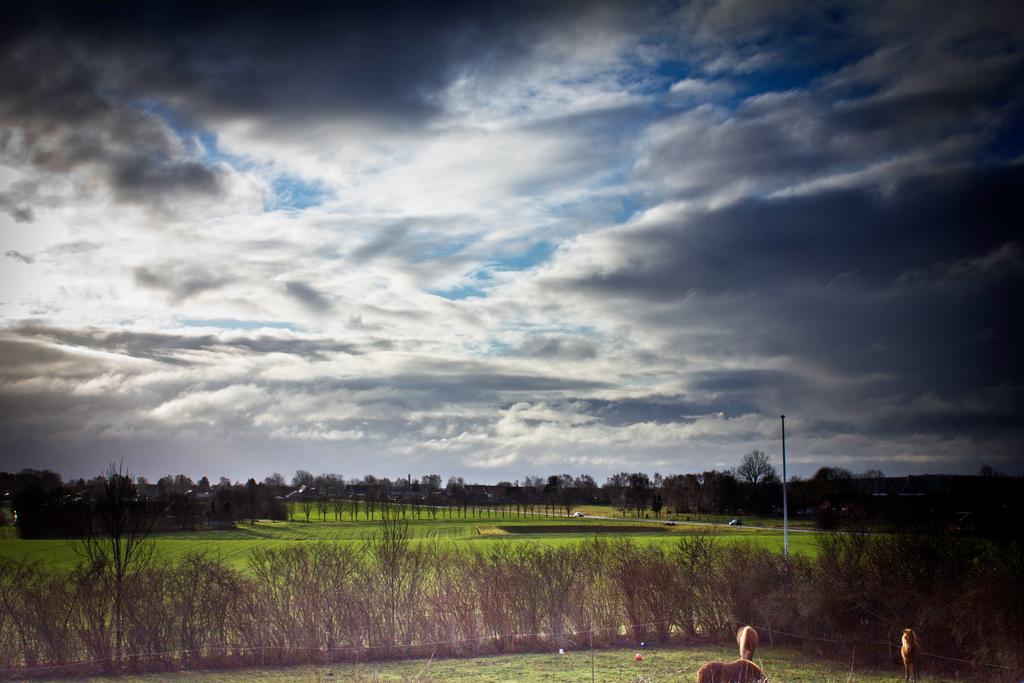How would you summarize this image in a sentence or two? In this image at the bottom right hand corner, I can see some animals, and there are some plants, and at the back, I can see many trees, background is the cloud and sky. 